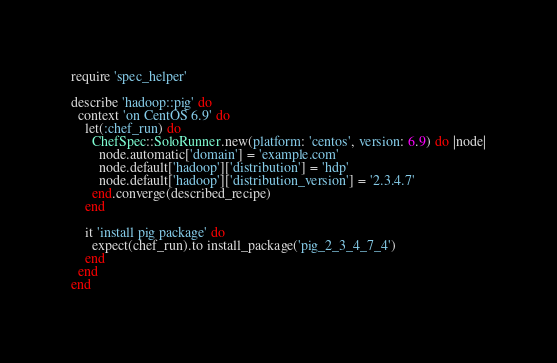<code> <loc_0><loc_0><loc_500><loc_500><_Ruby_>require 'spec_helper'

describe 'hadoop::pig' do
  context 'on CentOS 6.9' do
    let(:chef_run) do
      ChefSpec::SoloRunner.new(platform: 'centos', version: 6.9) do |node|
        node.automatic['domain'] = 'example.com'
        node.default['hadoop']['distribution'] = 'hdp'
        node.default['hadoop']['distribution_version'] = '2.3.4.7'
      end.converge(described_recipe)
    end

    it 'install pig package' do
      expect(chef_run).to install_package('pig_2_3_4_7_4')
    end
  end
end
</code> 